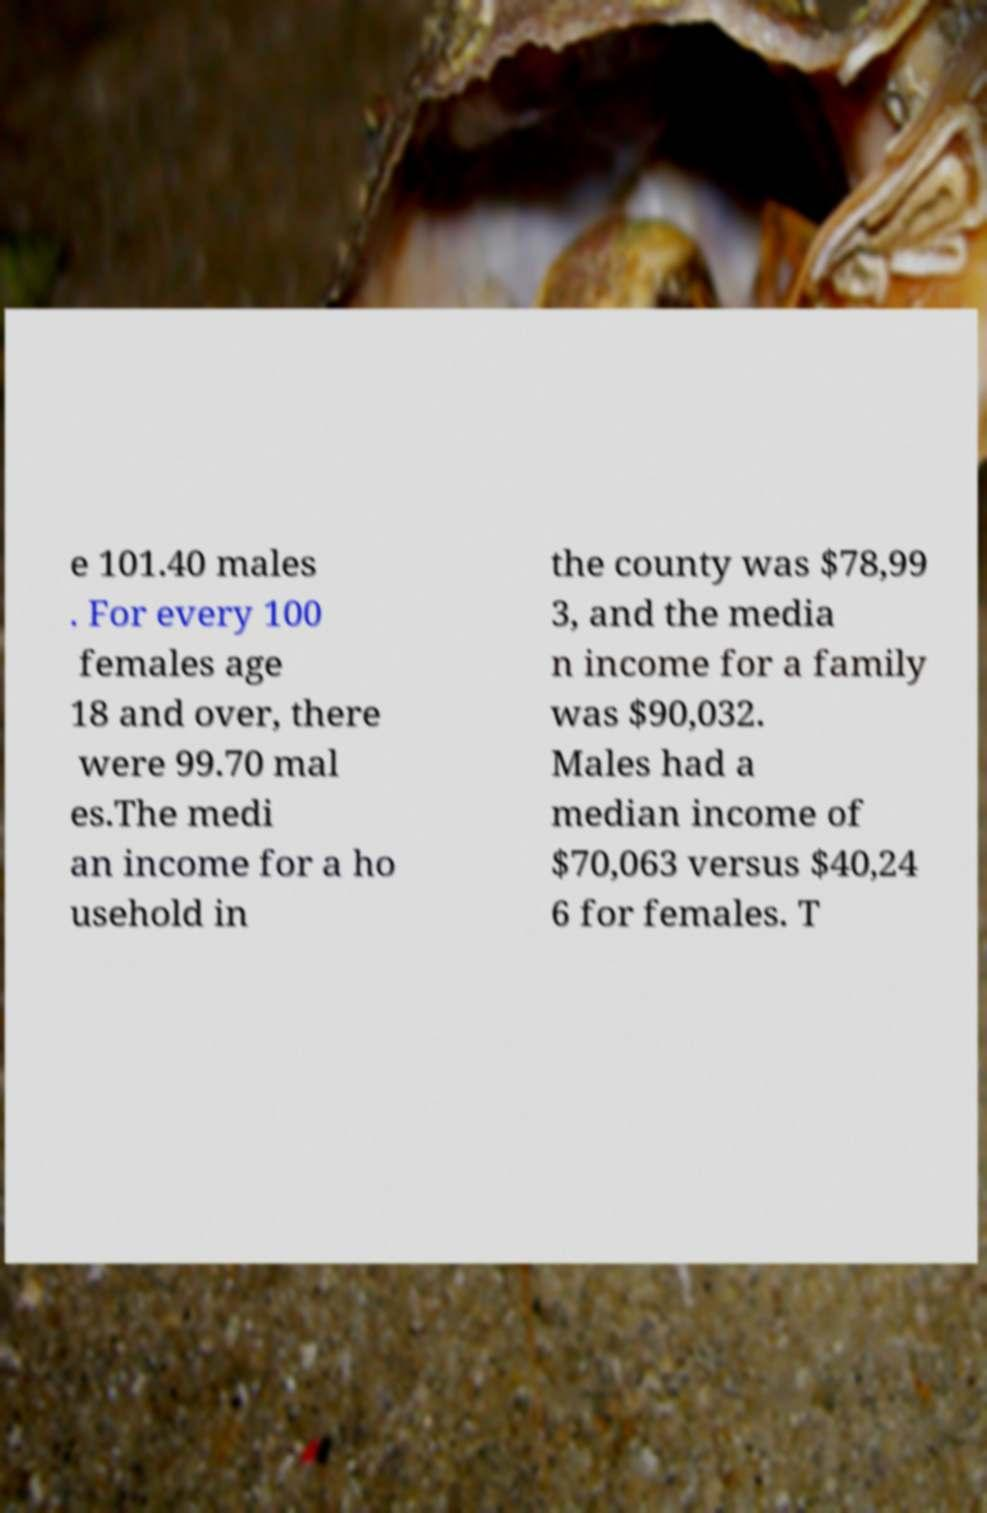Could you extract and type out the text from this image? e 101.40 males . For every 100 females age 18 and over, there were 99.70 mal es.The medi an income for a ho usehold in the county was $78,99 3, and the media n income for a family was $90,032. Males had a median income of $70,063 versus $40,24 6 for females. T 